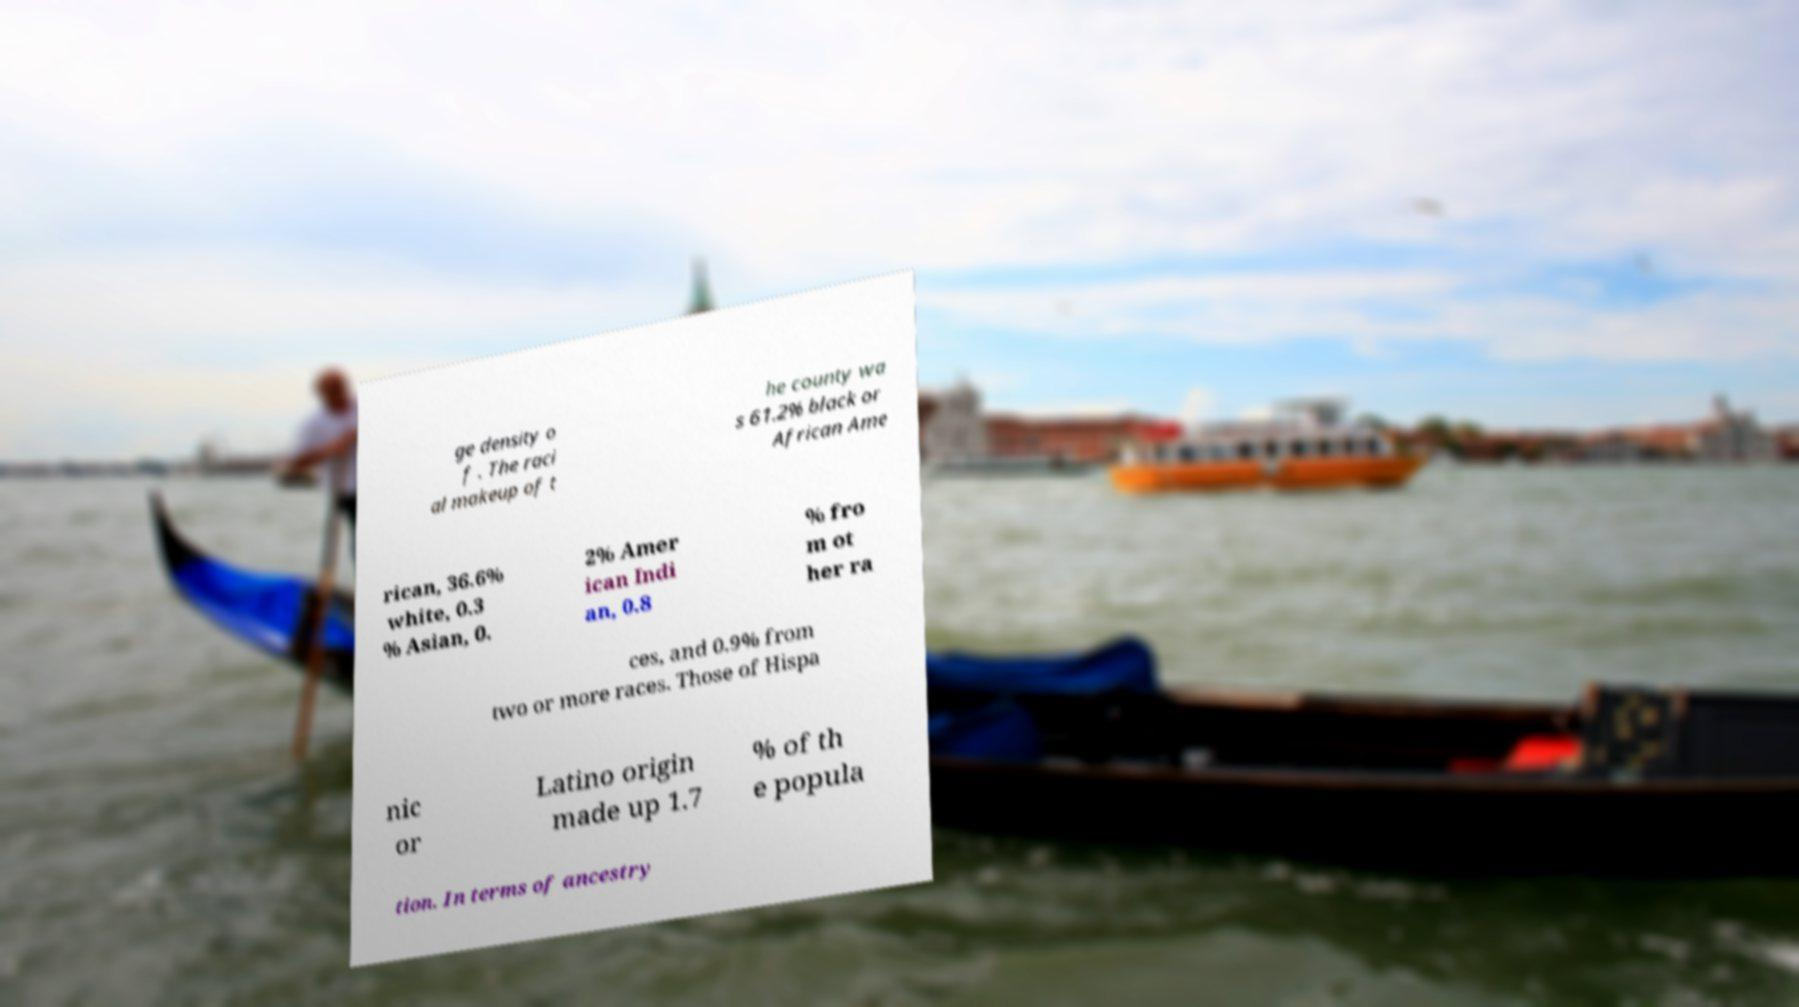There's text embedded in this image that I need extracted. Can you transcribe it verbatim? ge density o f . The raci al makeup of t he county wa s 61.2% black or African Ame rican, 36.6% white, 0.3 % Asian, 0. 2% Amer ican Indi an, 0.8 % fro m ot her ra ces, and 0.9% from two or more races. Those of Hispa nic or Latino origin made up 1.7 % of th e popula tion. In terms of ancestry 